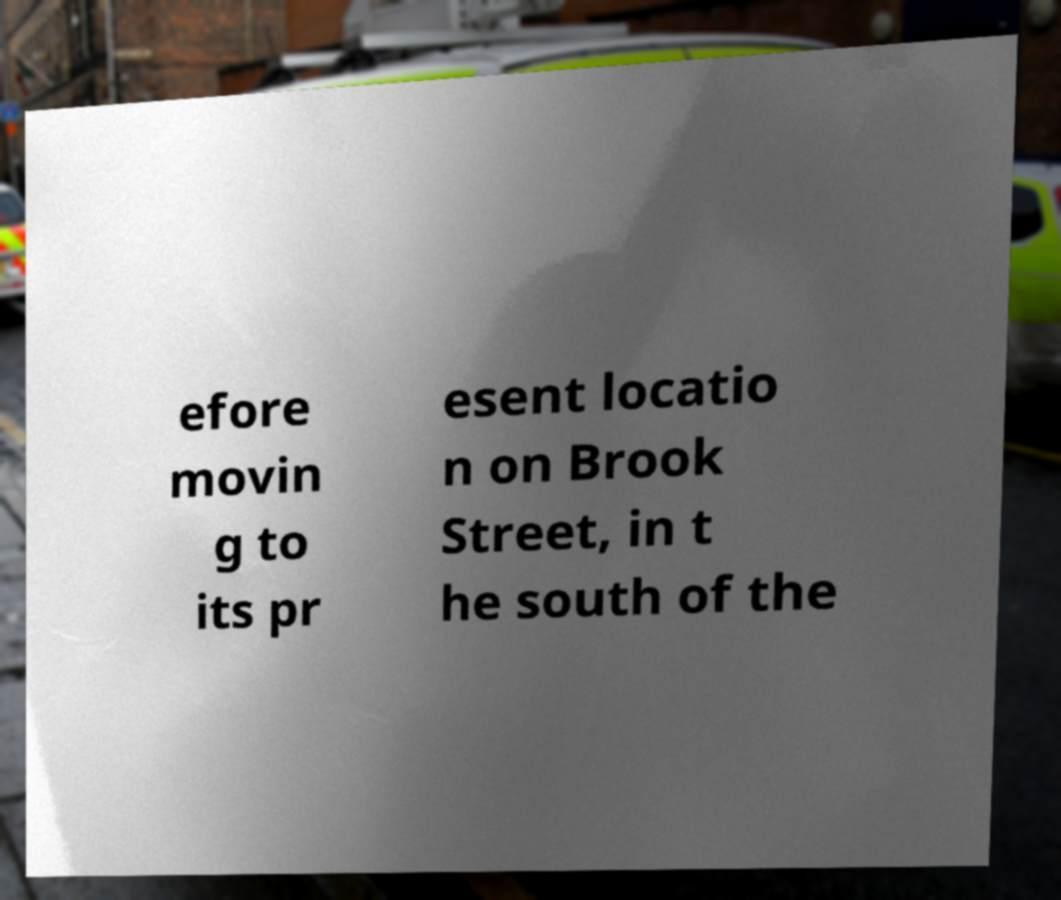Could you extract and type out the text from this image? efore movin g to its pr esent locatio n on Brook Street, in t he south of the 